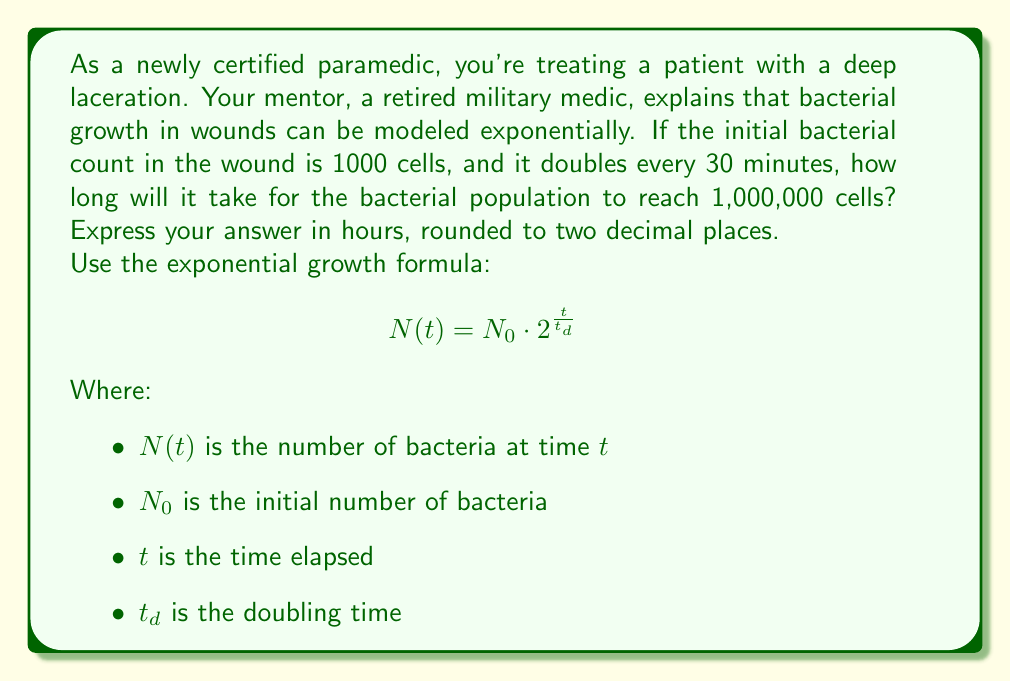Solve this math problem. Let's approach this step-by-step:

1) We're given:
   $N_0 = 1000$ (initial bacterial count)
   $N(t) = 1,000,000$ (target bacterial count)
   $t_d = 0.5$ hours (doubling time)

2) We need to find $t$. Let's substitute these values into the formula:

   $$ 1,000,000 = 1000 \cdot 2^{\frac{t}{0.5}} $$

3) Simplify the right side:

   $$ 1,000,000 = 1000 \cdot 2^{2t} $$

4) Divide both sides by 1000:

   $$ 1000 = 2^{2t} $$

5) Take the logarithm (base 2) of both sides:

   $$ \log_2(1000) = 2t $$

6) Solve for $t$:

   $$ t = \frac{\log_2(1000)}{2} $$

7) Calculate:
   $\log_2(1000) \approx 9.97$ (using a calculator)

   $$ t = \frac{9.97}{2} \approx 4.985 \text{ hours} $$

8) Rounding to two decimal places:

   $$ t \approx 4.99 \text{ hours} $$

This result shows how quickly bacterial infections can grow, emphasizing the importance of prompt and proper wound care in emergency medical situations.
Answer: 4.99 hours 